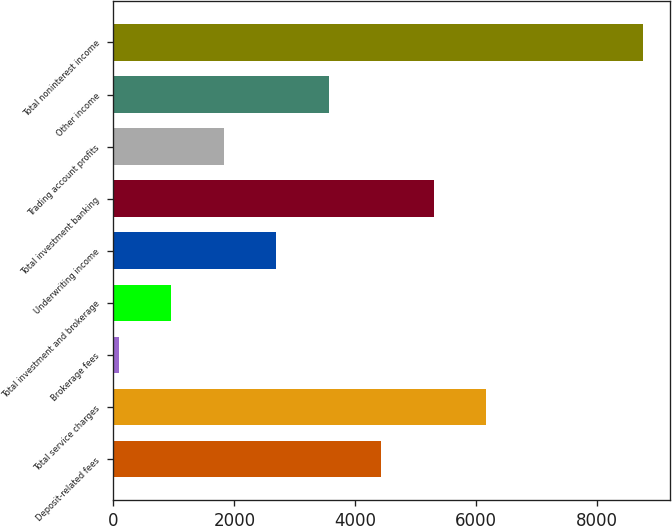Convert chart. <chart><loc_0><loc_0><loc_500><loc_500><bar_chart><fcel>Deposit-related fees<fcel>Total service charges<fcel>Brokerage fees<fcel>Total investment and brokerage<fcel>Underwriting income<fcel>Total investment banking<fcel>Trading account profits<fcel>Other income<fcel>Total noninterest income<nl><fcel>4428.5<fcel>6162.3<fcel>94<fcel>960.9<fcel>2694.7<fcel>5295.4<fcel>1827.8<fcel>3561.6<fcel>8763<nl></chart> 